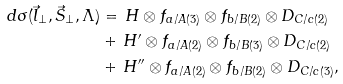Convert formula to latex. <formula><loc_0><loc_0><loc_500><loc_500>d \sigma ( \vec { l } _ { \perp } , \vec { S } _ { \perp } , \Lambda ) & = \, H \otimes f _ { a / A ( 3 ) } \otimes f _ { b / B ( 2 ) } \otimes D _ { C / c ( 2 ) } \\ & + \, H ^ { \prime } \otimes f _ { a / A ( 2 ) } \otimes f _ { b / B ( 3 ) } \otimes D _ { C / c ( 2 ) } \\ & + \, H ^ { \prime \prime } \otimes f _ { a / A ( 2 ) } \otimes f _ { b / B ( 2 ) } \otimes D _ { C / c ( 3 ) } ,</formula> 